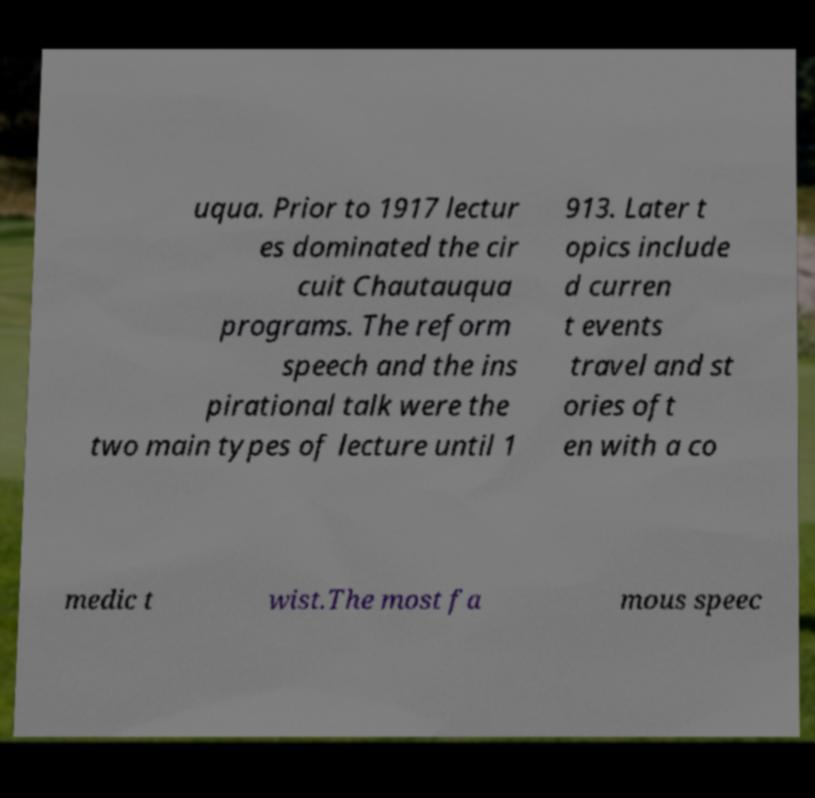Can you read and provide the text displayed in the image?This photo seems to have some interesting text. Can you extract and type it out for me? uqua. Prior to 1917 lectur es dominated the cir cuit Chautauqua programs. The reform speech and the ins pirational talk were the two main types of lecture until 1 913. Later t opics include d curren t events travel and st ories oft en with a co medic t wist.The most fa mous speec 